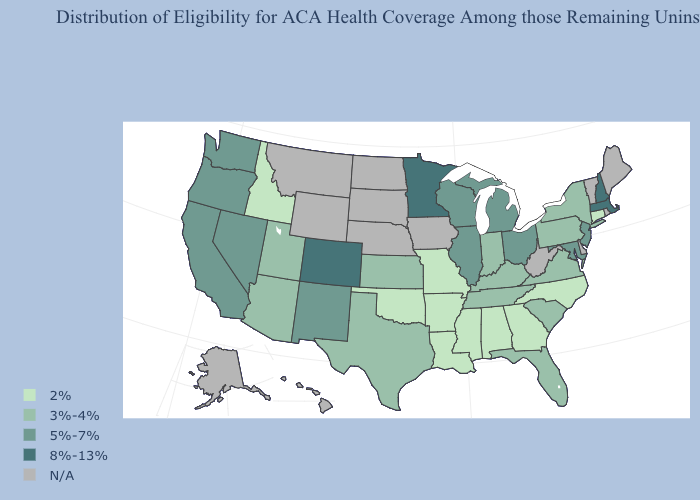Name the states that have a value in the range 3%-4%?
Quick response, please. Arizona, Florida, Indiana, Kansas, Kentucky, New York, Pennsylvania, South Carolina, Tennessee, Texas, Utah, Virginia. Which states have the lowest value in the South?
Answer briefly. Alabama, Arkansas, Georgia, Louisiana, Mississippi, North Carolina, Oklahoma. Which states have the lowest value in the Northeast?
Write a very short answer. Connecticut. What is the value of New York?
Concise answer only. 3%-4%. What is the value of Nebraska?
Quick response, please. N/A. Name the states that have a value in the range 8%-13%?
Write a very short answer. Colorado, Massachusetts, Minnesota, New Hampshire. What is the value of Indiana?
Answer briefly. 3%-4%. Does Missouri have the lowest value in the MidWest?
Short answer required. Yes. What is the value of Delaware?
Short answer required. N/A. What is the value of Michigan?
Be succinct. 5%-7%. Which states have the highest value in the USA?
Short answer required. Colorado, Massachusetts, Minnesota, New Hampshire. Which states hav the highest value in the West?
Quick response, please. Colorado. What is the highest value in states that border Maryland?
Quick response, please. 3%-4%. 